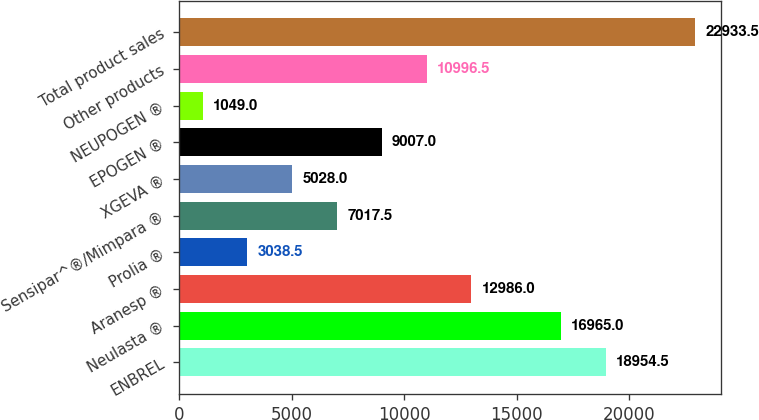Convert chart to OTSL. <chart><loc_0><loc_0><loc_500><loc_500><bar_chart><fcel>ENBREL<fcel>Neulasta ®<fcel>Aranesp ®<fcel>Prolia ®<fcel>Sensipar^®/Mimpara ®<fcel>XGEVA ®<fcel>EPOGEN ®<fcel>NEUPOGEN ®<fcel>Other products<fcel>Total product sales<nl><fcel>18954.5<fcel>16965<fcel>12986<fcel>3038.5<fcel>7017.5<fcel>5028<fcel>9007<fcel>1049<fcel>10996.5<fcel>22933.5<nl></chart> 